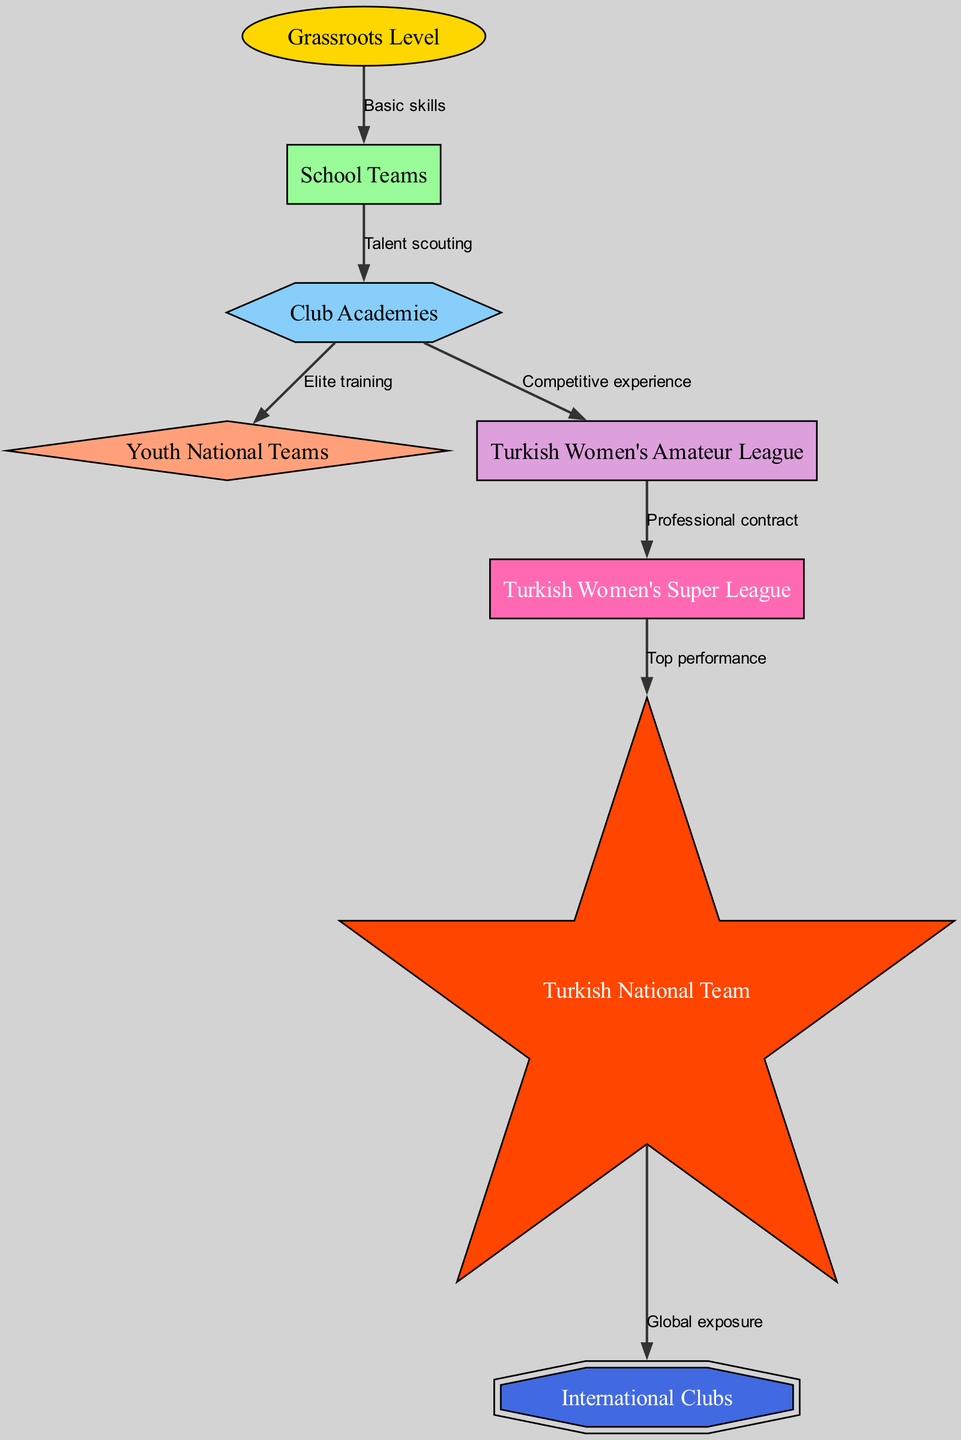What is the starting point of the career progression for young female footballers? The diagram indicates that the progression begins at the "Grassroots Level" node, which serves as the foundation for developing basic skills before moving to other levels.
Answer: Grassroots Level What type of experience does the "Academy" provide before athletes advance to professional status? The "Academy" node connects to both "Youth National Teams" through "Elite training" and to "Turkish Women's Amateur League" through "Competitive experience," indicating that academies focus on providing both high-level training and practical playing experience.
Answer: Competitive experience and Elite training How many total nodes are present in the diagram? By counting the distinct nodes listed in the diagram, it is clear there are 8 nodes representing different stages or aspects of the career progression for female footballers.
Answer: 8 What is the direct connection between "Pro" and "National" levels? The edge labeled "Top performance" signifies that the athletes transition from the professional level to the national level upon exhibiting remarkable skills and performance in their respective clubs.
Answer: Top performance What is the final destination in the career pathway for the footballers? The diagram concludes with the "International Clubs" node, showing that the ultimate goal is playing at an international level after progressing through the national stage.
Answer: International Clubs What essential skill development occurs at the "School Teams" level? The diagram illustrates that athletes gain access to talent scouting from "School Teams," which is essential for identifying promising players who can progress to higher levels, such as club academies.
Answer: Talent scouting Which node represents the elite competitive stage immediately before national representation? The "Pro" node indicates the immediate competitive level before potentially transitioning to representing the national team, showing a direct link between professional competition and national selection.
Answer: Pro What type of league is represented just before the professional level in the career pathway? The "Turkish Women's Amateur League" serves as the last competitive stage before players earn a professional contract, as seen from the node hierarchy in the diagram.
Answer: Turkish Women's Amateur League 